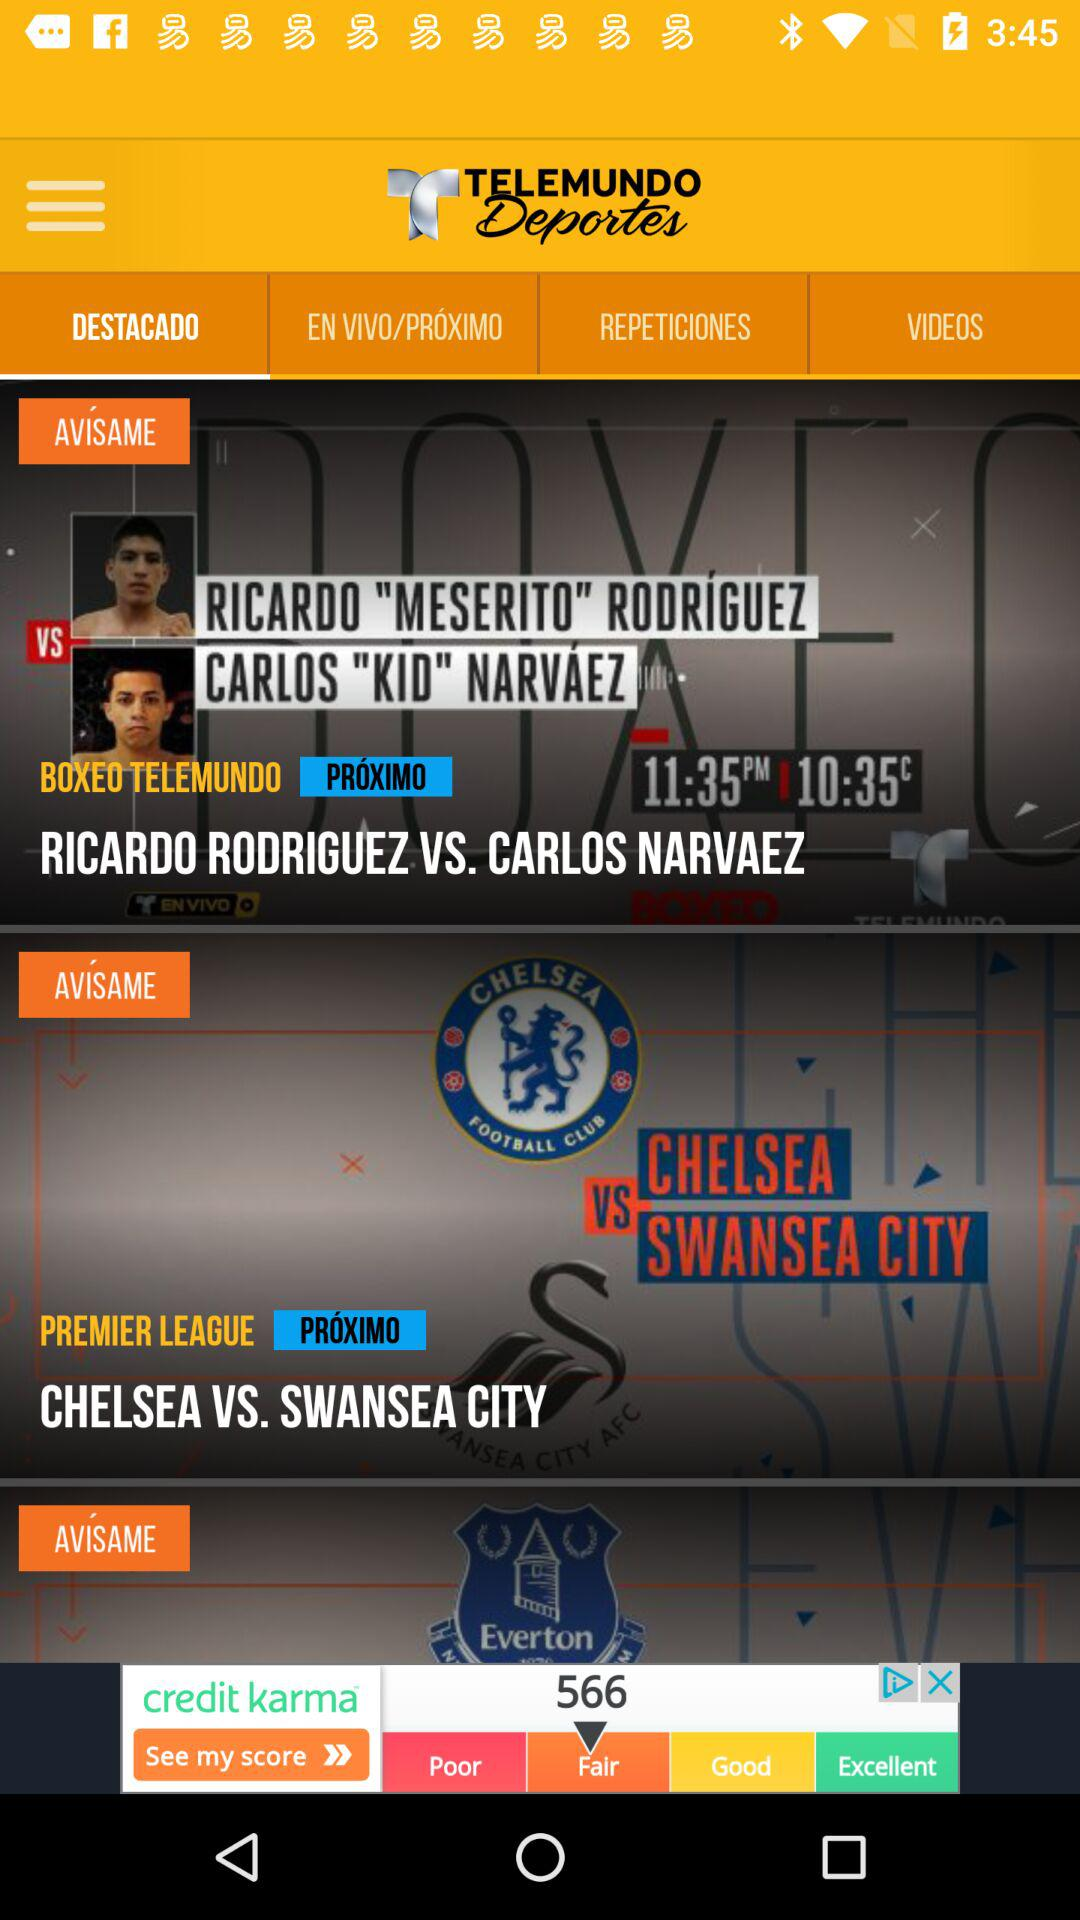Which tab has been selected? The tab "DESTACADO" has been selected. 